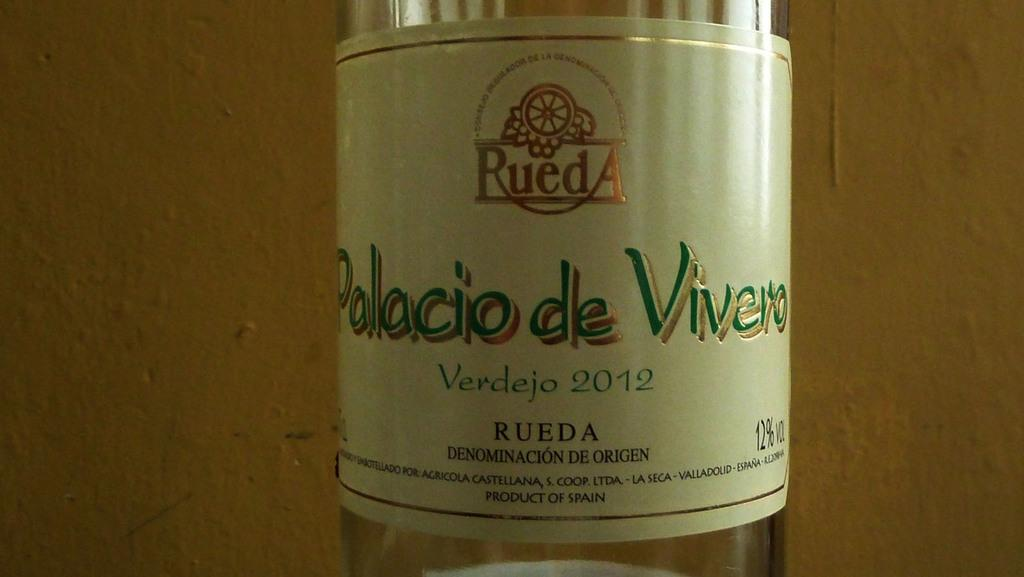<image>
Provide a brief description of the given image. A bottle label for Polacio de Vivero Verdejo 2012. 